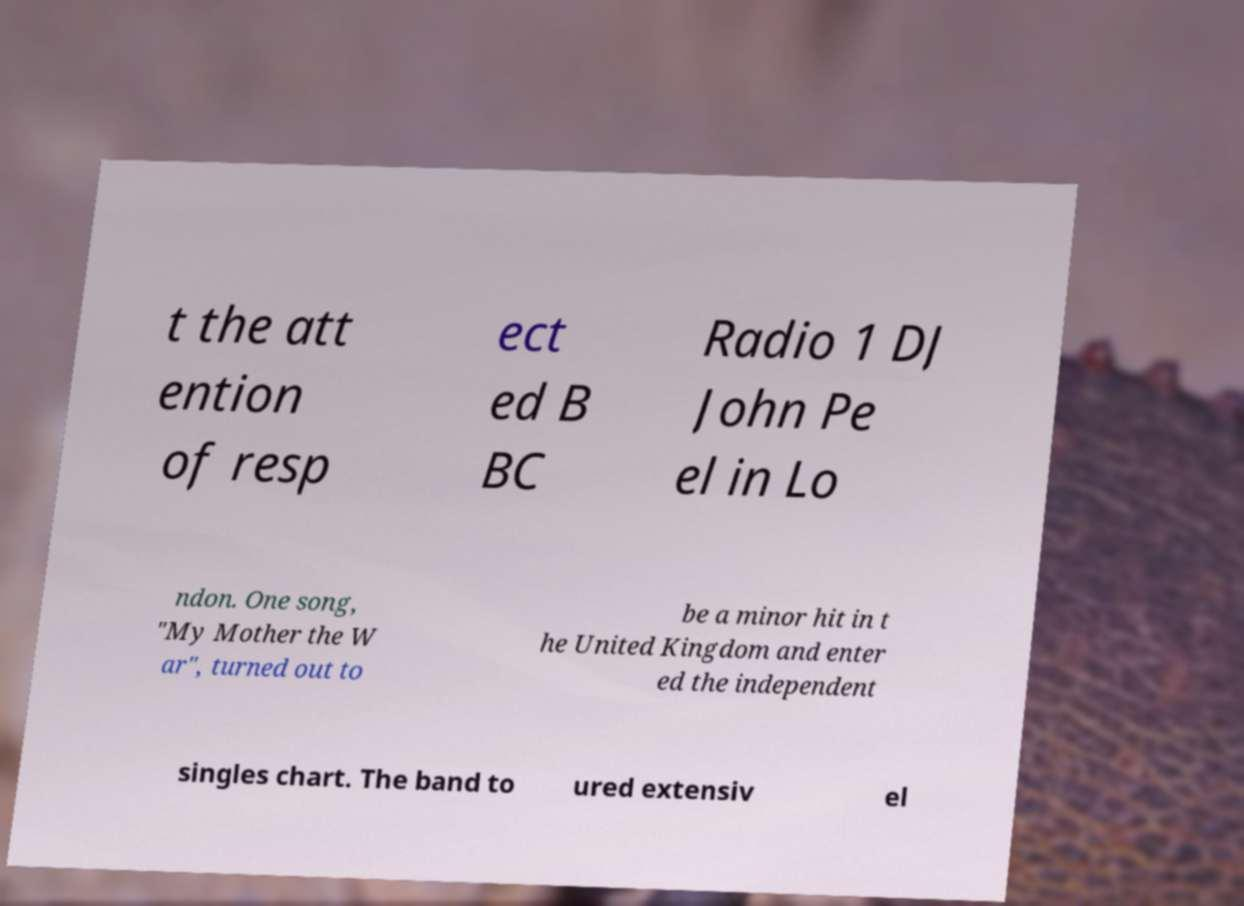Please read and relay the text visible in this image. What does it say? t the att ention of resp ect ed B BC Radio 1 DJ John Pe el in Lo ndon. One song, "My Mother the W ar", turned out to be a minor hit in t he United Kingdom and enter ed the independent singles chart. The band to ured extensiv el 